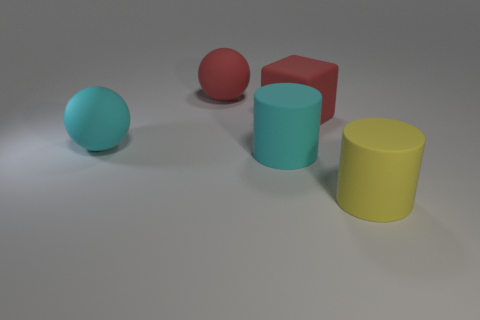Are there fewer red matte objects right of the large red matte sphere than cylinders?
Give a very brief answer. Yes. Is there any other thing that is the same shape as the big yellow matte thing?
Your answer should be very brief. Yes. Are there fewer big yellow objects than large purple matte cubes?
Your response must be concise. No. There is a cylinder in front of the large rubber cylinder behind the big yellow thing; what is its color?
Ensure brevity in your answer.  Yellow. What is the material of the large ball that is behind the matte ball that is to the left of the red matte thing to the left of the large rubber cube?
Offer a very short reply. Rubber. Does the matte cylinder behind the yellow object have the same size as the red ball?
Keep it short and to the point. Yes. There is a yellow cylinder in front of the cyan cylinder; what is its material?
Your answer should be very brief. Rubber. Are there more big gray metal things than large yellow cylinders?
Make the answer very short. No. How many things are cylinders that are behind the yellow cylinder or tiny red shiny cylinders?
Keep it short and to the point. 1. There is a large cyan object behind the big cyan cylinder; what number of large cylinders are behind it?
Provide a short and direct response. 0. 